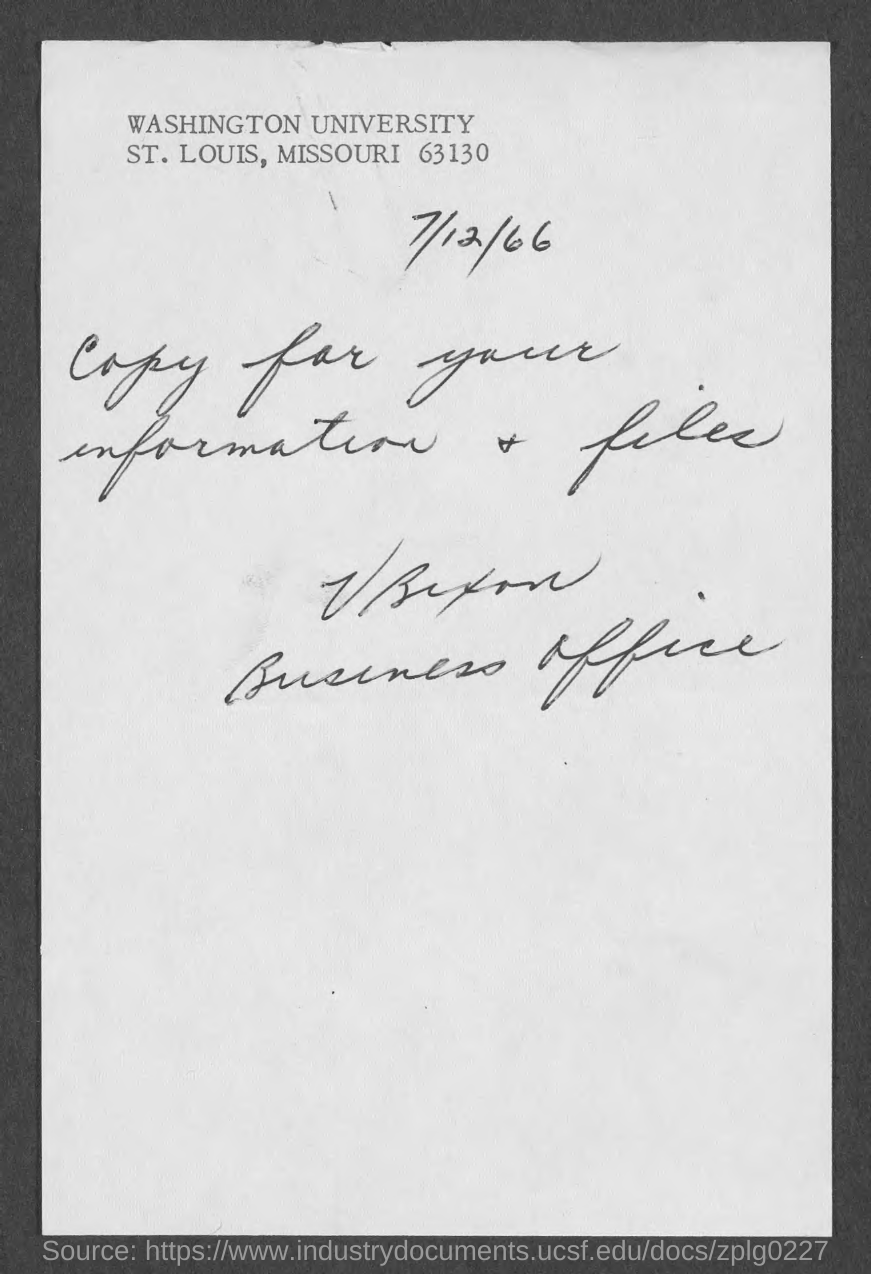What is the date in the document?
Your answer should be very brief. 7/12/66. 